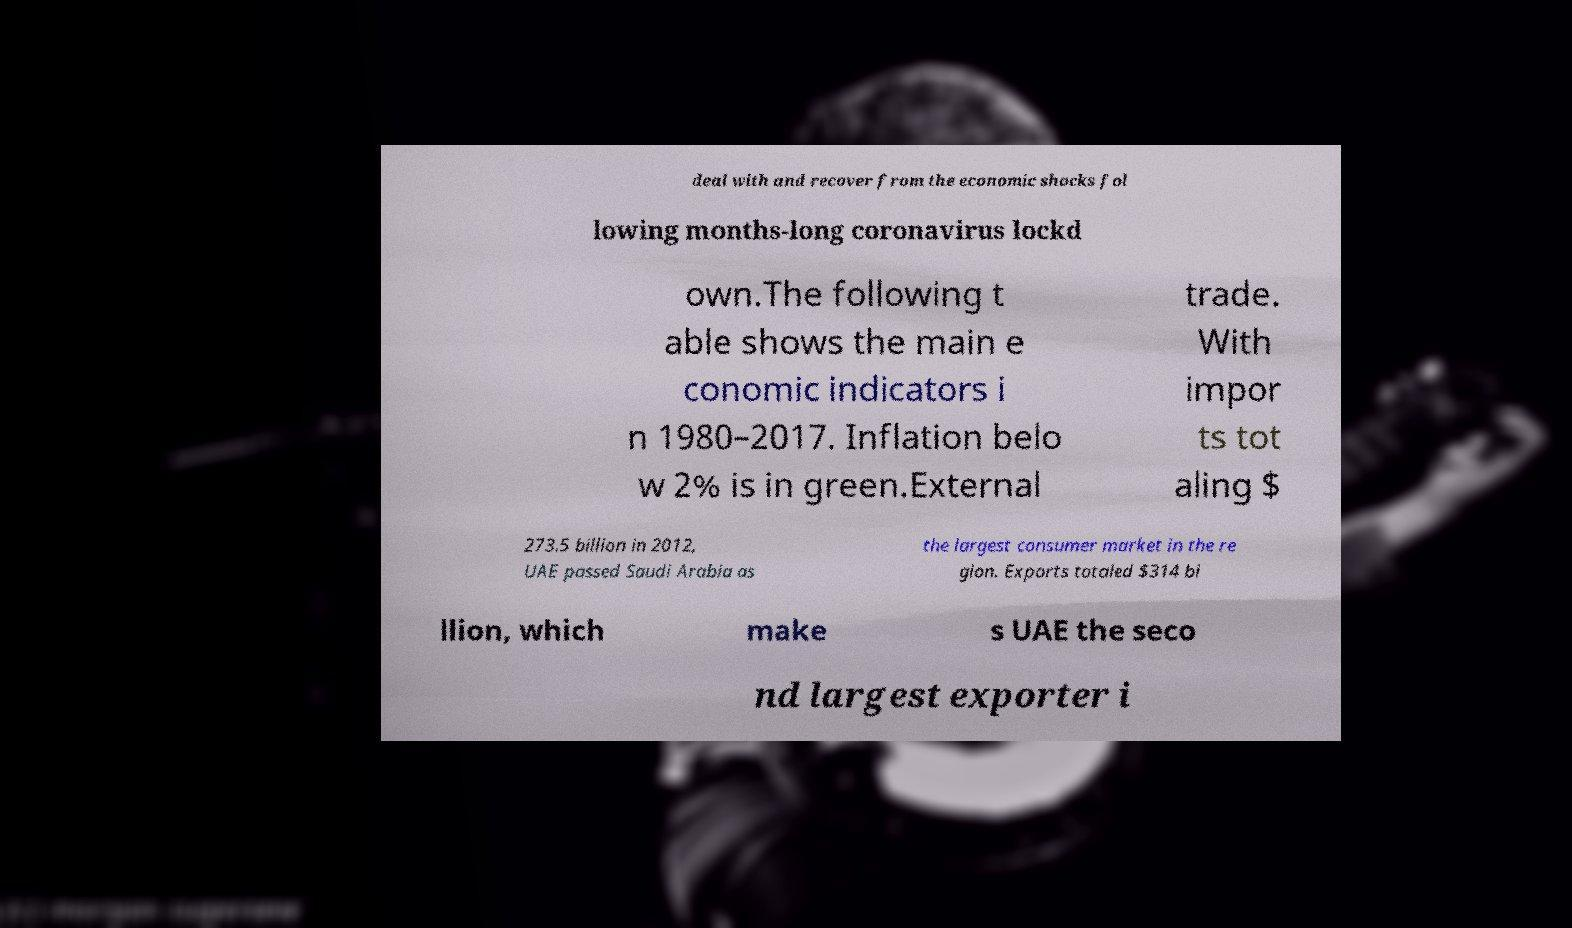Can you accurately transcribe the text from the provided image for me? deal with and recover from the economic shocks fol lowing months-long coronavirus lockd own.The following t able shows the main e conomic indicators i n 1980–2017. Inflation belo w 2% is in green.External trade. With impor ts tot aling $ 273.5 billion in 2012, UAE passed Saudi Arabia as the largest consumer market in the re gion. Exports totaled $314 bi llion, which make s UAE the seco nd largest exporter i 